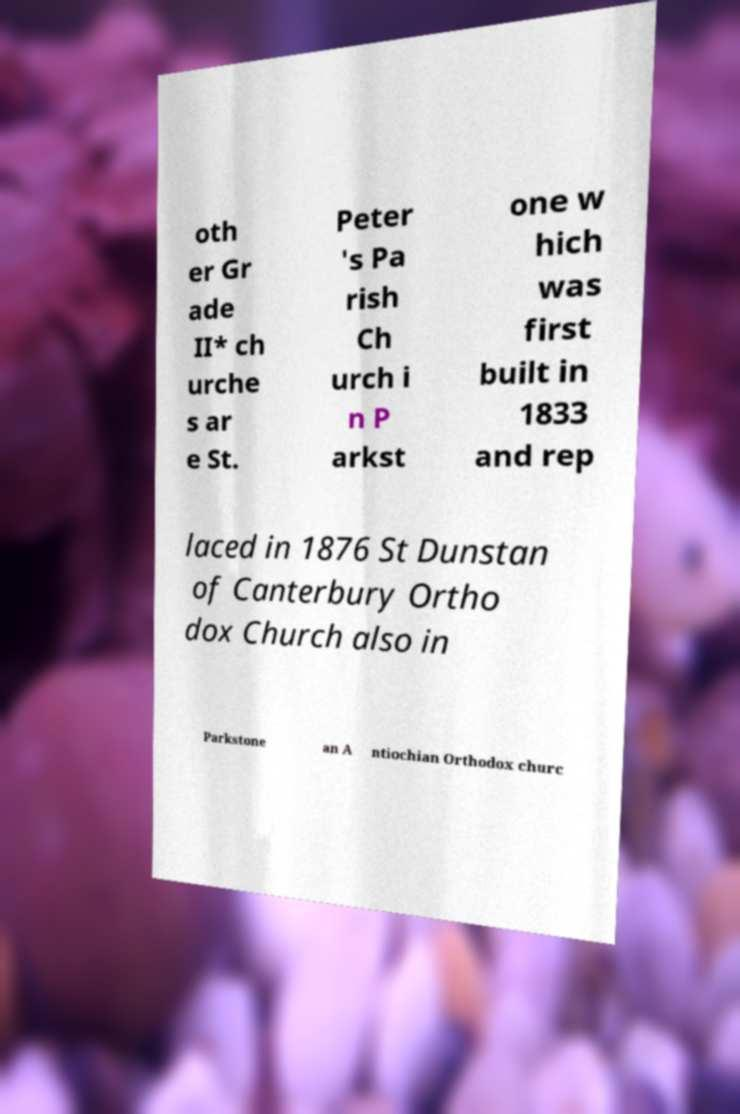For documentation purposes, I need the text within this image transcribed. Could you provide that? oth er Gr ade II* ch urche s ar e St. Peter 's Pa rish Ch urch i n P arkst one w hich was first built in 1833 and rep laced in 1876 St Dunstan of Canterbury Ortho dox Church also in Parkstone an A ntiochian Orthodox churc 